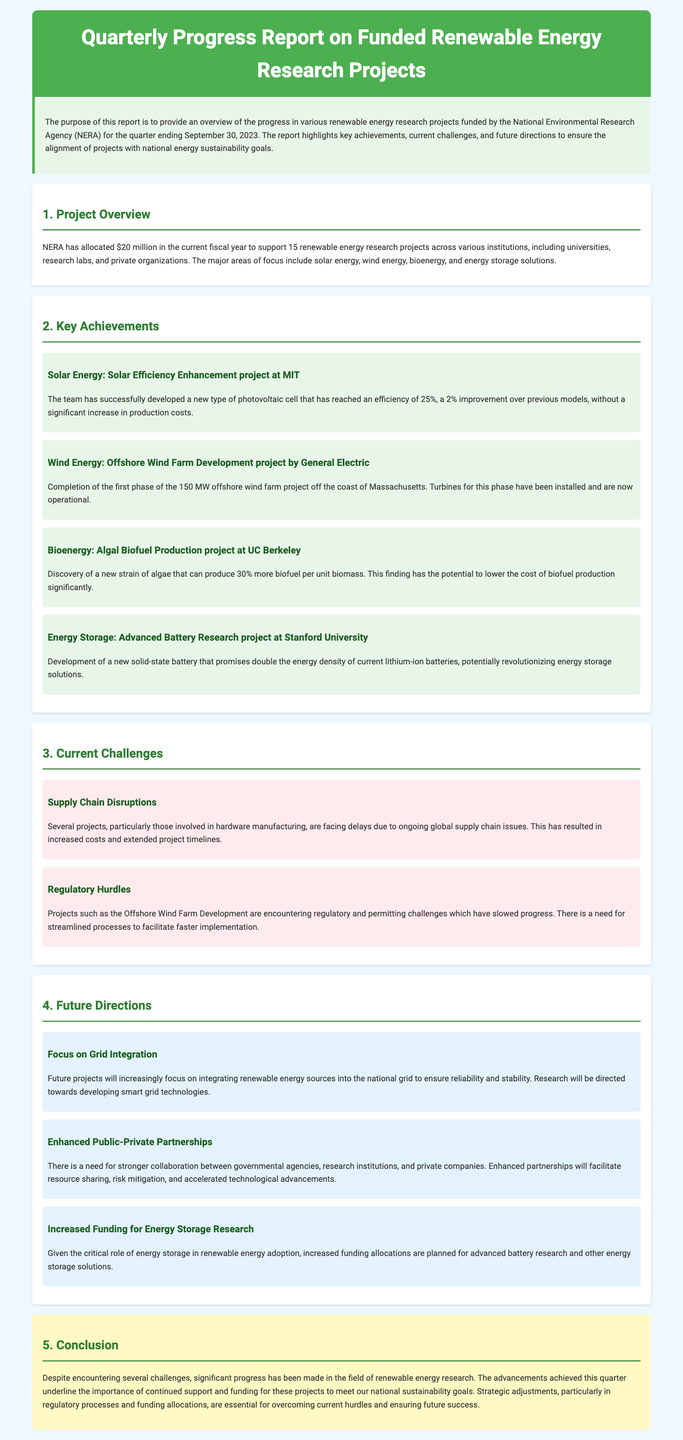What is the total funding allocated for renewable energy research projects? The total funding allocated by NERA is stated in the document as $20 million for the current fiscal year.
Answer: $20 million How many renewable energy research projects are funded? The document specifies that 15 renewable energy research projects are funded.
Answer: 15 What efficiency percentage has the new photovoltaic cell reached? It states that the new photovoltaic cell has reached an efficiency of 25%.
Answer: 25% Which institution is responsible for the Energy Storage project? The document mentions that the Advanced Battery Research project is at Stanford University.
Answer: Stanford University What is one challenge identified in the report? The report highlights supply chain disruptions as one of the current challenges faced by several projects.
Answer: Supply chain disruptions What is an emerging focus for future projects? The document indicates that future projects will increasingly focus on grid integration to ensure reliability.
Answer: Grid integration Which project discovered a new strain of algae? The Algal Biofuel Production project at UC Berkeley is responsible for discovering a new strain of algae.
Answer: UC Berkeley What is the anticipated impact of enhanced public-private partnerships? The expectation is that enhanced partnerships will facilitate resource sharing and accelerate technological advancements.
Answer: Accelerate technological advancements What is an expected development for energy storage research? The document outlines that increased funding allocations are planned for advanced battery research.
Answer: Increased funding allocations 